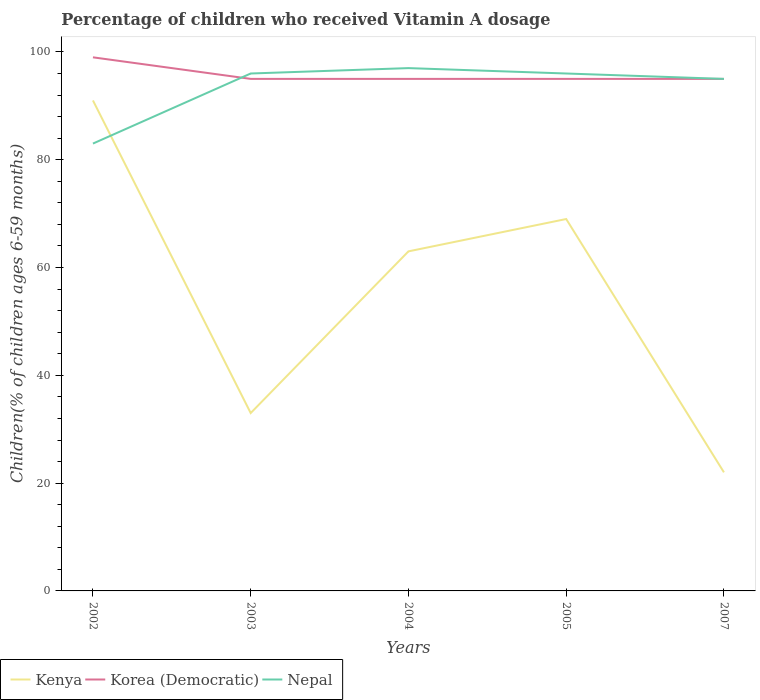How many different coloured lines are there?
Give a very brief answer. 3. Is the number of lines equal to the number of legend labels?
Offer a terse response. Yes. Across all years, what is the maximum percentage of children who received Vitamin A dosage in Nepal?
Your answer should be compact. 83. In which year was the percentage of children who received Vitamin A dosage in Kenya maximum?
Give a very brief answer. 2007. What is the difference between the highest and the second highest percentage of children who received Vitamin A dosage in Korea (Democratic)?
Offer a terse response. 4. What is the difference between the highest and the lowest percentage of children who received Vitamin A dosage in Korea (Democratic)?
Your answer should be compact. 1. Is the percentage of children who received Vitamin A dosage in Kenya strictly greater than the percentage of children who received Vitamin A dosage in Nepal over the years?
Ensure brevity in your answer.  No. How many lines are there?
Offer a very short reply. 3. Are the values on the major ticks of Y-axis written in scientific E-notation?
Make the answer very short. No. Does the graph contain any zero values?
Your response must be concise. No. Does the graph contain grids?
Give a very brief answer. No. How are the legend labels stacked?
Your answer should be compact. Horizontal. What is the title of the graph?
Give a very brief answer. Percentage of children who received Vitamin A dosage. Does "Lesotho" appear as one of the legend labels in the graph?
Your answer should be very brief. No. What is the label or title of the Y-axis?
Give a very brief answer. Children(% of children ages 6-59 months). What is the Children(% of children ages 6-59 months) in Kenya in 2002?
Keep it short and to the point. 91. What is the Children(% of children ages 6-59 months) of Nepal in 2002?
Ensure brevity in your answer.  83. What is the Children(% of children ages 6-59 months) of Nepal in 2003?
Give a very brief answer. 96. What is the Children(% of children ages 6-59 months) of Kenya in 2004?
Make the answer very short. 63. What is the Children(% of children ages 6-59 months) of Nepal in 2004?
Your answer should be compact. 97. What is the Children(% of children ages 6-59 months) of Kenya in 2005?
Give a very brief answer. 69. What is the Children(% of children ages 6-59 months) of Nepal in 2005?
Provide a succinct answer. 96. What is the Children(% of children ages 6-59 months) in Korea (Democratic) in 2007?
Your response must be concise. 95. Across all years, what is the maximum Children(% of children ages 6-59 months) in Kenya?
Make the answer very short. 91. Across all years, what is the maximum Children(% of children ages 6-59 months) of Korea (Democratic)?
Keep it short and to the point. 99. Across all years, what is the maximum Children(% of children ages 6-59 months) of Nepal?
Give a very brief answer. 97. Across all years, what is the minimum Children(% of children ages 6-59 months) of Kenya?
Ensure brevity in your answer.  22. Across all years, what is the minimum Children(% of children ages 6-59 months) in Korea (Democratic)?
Ensure brevity in your answer.  95. What is the total Children(% of children ages 6-59 months) in Kenya in the graph?
Offer a terse response. 278. What is the total Children(% of children ages 6-59 months) in Korea (Democratic) in the graph?
Offer a terse response. 479. What is the total Children(% of children ages 6-59 months) of Nepal in the graph?
Your answer should be very brief. 467. What is the difference between the Children(% of children ages 6-59 months) of Kenya in 2002 and that in 2003?
Provide a short and direct response. 58. What is the difference between the Children(% of children ages 6-59 months) of Nepal in 2002 and that in 2003?
Provide a short and direct response. -13. What is the difference between the Children(% of children ages 6-59 months) of Nepal in 2002 and that in 2004?
Make the answer very short. -14. What is the difference between the Children(% of children ages 6-59 months) of Kenya in 2002 and that in 2007?
Provide a succinct answer. 69. What is the difference between the Children(% of children ages 6-59 months) in Korea (Democratic) in 2002 and that in 2007?
Offer a very short reply. 4. What is the difference between the Children(% of children ages 6-59 months) in Nepal in 2002 and that in 2007?
Your answer should be compact. -12. What is the difference between the Children(% of children ages 6-59 months) of Kenya in 2003 and that in 2005?
Keep it short and to the point. -36. What is the difference between the Children(% of children ages 6-59 months) in Korea (Democratic) in 2003 and that in 2005?
Give a very brief answer. 0. What is the difference between the Children(% of children ages 6-59 months) in Nepal in 2003 and that in 2005?
Offer a terse response. 0. What is the difference between the Children(% of children ages 6-59 months) of Korea (Democratic) in 2003 and that in 2007?
Your answer should be compact. 0. What is the difference between the Children(% of children ages 6-59 months) of Nepal in 2003 and that in 2007?
Offer a very short reply. 1. What is the difference between the Children(% of children ages 6-59 months) of Korea (Democratic) in 2004 and that in 2005?
Give a very brief answer. 0. What is the difference between the Children(% of children ages 6-59 months) of Nepal in 2004 and that in 2005?
Your response must be concise. 1. What is the difference between the Children(% of children ages 6-59 months) in Kenya in 2005 and that in 2007?
Your answer should be compact. 47. What is the difference between the Children(% of children ages 6-59 months) of Korea (Democratic) in 2005 and that in 2007?
Your answer should be compact. 0. What is the difference between the Children(% of children ages 6-59 months) of Kenya in 2002 and the Children(% of children ages 6-59 months) of Korea (Democratic) in 2003?
Your answer should be compact. -4. What is the difference between the Children(% of children ages 6-59 months) in Kenya in 2002 and the Children(% of children ages 6-59 months) in Nepal in 2003?
Ensure brevity in your answer.  -5. What is the difference between the Children(% of children ages 6-59 months) of Kenya in 2002 and the Children(% of children ages 6-59 months) of Korea (Democratic) in 2004?
Keep it short and to the point. -4. What is the difference between the Children(% of children ages 6-59 months) of Korea (Democratic) in 2002 and the Children(% of children ages 6-59 months) of Nepal in 2004?
Your response must be concise. 2. What is the difference between the Children(% of children ages 6-59 months) in Korea (Democratic) in 2002 and the Children(% of children ages 6-59 months) in Nepal in 2005?
Ensure brevity in your answer.  3. What is the difference between the Children(% of children ages 6-59 months) of Kenya in 2003 and the Children(% of children ages 6-59 months) of Korea (Democratic) in 2004?
Ensure brevity in your answer.  -62. What is the difference between the Children(% of children ages 6-59 months) of Kenya in 2003 and the Children(% of children ages 6-59 months) of Nepal in 2004?
Provide a short and direct response. -64. What is the difference between the Children(% of children ages 6-59 months) in Kenya in 2003 and the Children(% of children ages 6-59 months) in Korea (Democratic) in 2005?
Offer a terse response. -62. What is the difference between the Children(% of children ages 6-59 months) in Kenya in 2003 and the Children(% of children ages 6-59 months) in Nepal in 2005?
Provide a short and direct response. -63. What is the difference between the Children(% of children ages 6-59 months) of Korea (Democratic) in 2003 and the Children(% of children ages 6-59 months) of Nepal in 2005?
Give a very brief answer. -1. What is the difference between the Children(% of children ages 6-59 months) in Kenya in 2003 and the Children(% of children ages 6-59 months) in Korea (Democratic) in 2007?
Give a very brief answer. -62. What is the difference between the Children(% of children ages 6-59 months) in Kenya in 2003 and the Children(% of children ages 6-59 months) in Nepal in 2007?
Give a very brief answer. -62. What is the difference between the Children(% of children ages 6-59 months) in Kenya in 2004 and the Children(% of children ages 6-59 months) in Korea (Democratic) in 2005?
Ensure brevity in your answer.  -32. What is the difference between the Children(% of children ages 6-59 months) in Kenya in 2004 and the Children(% of children ages 6-59 months) in Nepal in 2005?
Give a very brief answer. -33. What is the difference between the Children(% of children ages 6-59 months) in Kenya in 2004 and the Children(% of children ages 6-59 months) in Korea (Democratic) in 2007?
Ensure brevity in your answer.  -32. What is the difference between the Children(% of children ages 6-59 months) of Kenya in 2004 and the Children(% of children ages 6-59 months) of Nepal in 2007?
Give a very brief answer. -32. What is the difference between the Children(% of children ages 6-59 months) in Kenya in 2005 and the Children(% of children ages 6-59 months) in Korea (Democratic) in 2007?
Give a very brief answer. -26. What is the difference between the Children(% of children ages 6-59 months) in Kenya in 2005 and the Children(% of children ages 6-59 months) in Nepal in 2007?
Ensure brevity in your answer.  -26. What is the difference between the Children(% of children ages 6-59 months) of Korea (Democratic) in 2005 and the Children(% of children ages 6-59 months) of Nepal in 2007?
Offer a very short reply. 0. What is the average Children(% of children ages 6-59 months) of Kenya per year?
Provide a succinct answer. 55.6. What is the average Children(% of children ages 6-59 months) in Korea (Democratic) per year?
Keep it short and to the point. 95.8. What is the average Children(% of children ages 6-59 months) in Nepal per year?
Provide a short and direct response. 93.4. In the year 2002, what is the difference between the Children(% of children ages 6-59 months) of Kenya and Children(% of children ages 6-59 months) of Nepal?
Your response must be concise. 8. In the year 2002, what is the difference between the Children(% of children ages 6-59 months) of Korea (Democratic) and Children(% of children ages 6-59 months) of Nepal?
Provide a short and direct response. 16. In the year 2003, what is the difference between the Children(% of children ages 6-59 months) in Kenya and Children(% of children ages 6-59 months) in Korea (Democratic)?
Your answer should be compact. -62. In the year 2003, what is the difference between the Children(% of children ages 6-59 months) in Kenya and Children(% of children ages 6-59 months) in Nepal?
Offer a terse response. -63. In the year 2003, what is the difference between the Children(% of children ages 6-59 months) of Korea (Democratic) and Children(% of children ages 6-59 months) of Nepal?
Give a very brief answer. -1. In the year 2004, what is the difference between the Children(% of children ages 6-59 months) of Kenya and Children(% of children ages 6-59 months) of Korea (Democratic)?
Ensure brevity in your answer.  -32. In the year 2004, what is the difference between the Children(% of children ages 6-59 months) in Kenya and Children(% of children ages 6-59 months) in Nepal?
Make the answer very short. -34. In the year 2004, what is the difference between the Children(% of children ages 6-59 months) in Korea (Democratic) and Children(% of children ages 6-59 months) in Nepal?
Your answer should be very brief. -2. In the year 2005, what is the difference between the Children(% of children ages 6-59 months) of Kenya and Children(% of children ages 6-59 months) of Korea (Democratic)?
Offer a very short reply. -26. In the year 2005, what is the difference between the Children(% of children ages 6-59 months) of Korea (Democratic) and Children(% of children ages 6-59 months) of Nepal?
Offer a very short reply. -1. In the year 2007, what is the difference between the Children(% of children ages 6-59 months) of Kenya and Children(% of children ages 6-59 months) of Korea (Democratic)?
Your answer should be compact. -73. In the year 2007, what is the difference between the Children(% of children ages 6-59 months) in Kenya and Children(% of children ages 6-59 months) in Nepal?
Ensure brevity in your answer.  -73. In the year 2007, what is the difference between the Children(% of children ages 6-59 months) of Korea (Democratic) and Children(% of children ages 6-59 months) of Nepal?
Your response must be concise. 0. What is the ratio of the Children(% of children ages 6-59 months) of Kenya in 2002 to that in 2003?
Your answer should be very brief. 2.76. What is the ratio of the Children(% of children ages 6-59 months) of Korea (Democratic) in 2002 to that in 2003?
Give a very brief answer. 1.04. What is the ratio of the Children(% of children ages 6-59 months) of Nepal in 2002 to that in 2003?
Your answer should be very brief. 0.86. What is the ratio of the Children(% of children ages 6-59 months) of Kenya in 2002 to that in 2004?
Your answer should be compact. 1.44. What is the ratio of the Children(% of children ages 6-59 months) in Korea (Democratic) in 2002 to that in 2004?
Give a very brief answer. 1.04. What is the ratio of the Children(% of children ages 6-59 months) in Nepal in 2002 to that in 2004?
Keep it short and to the point. 0.86. What is the ratio of the Children(% of children ages 6-59 months) of Kenya in 2002 to that in 2005?
Offer a very short reply. 1.32. What is the ratio of the Children(% of children ages 6-59 months) in Korea (Democratic) in 2002 to that in 2005?
Offer a terse response. 1.04. What is the ratio of the Children(% of children ages 6-59 months) of Nepal in 2002 to that in 2005?
Provide a short and direct response. 0.86. What is the ratio of the Children(% of children ages 6-59 months) of Kenya in 2002 to that in 2007?
Your response must be concise. 4.14. What is the ratio of the Children(% of children ages 6-59 months) in Korea (Democratic) in 2002 to that in 2007?
Provide a short and direct response. 1.04. What is the ratio of the Children(% of children ages 6-59 months) of Nepal in 2002 to that in 2007?
Ensure brevity in your answer.  0.87. What is the ratio of the Children(% of children ages 6-59 months) of Kenya in 2003 to that in 2004?
Keep it short and to the point. 0.52. What is the ratio of the Children(% of children ages 6-59 months) in Korea (Democratic) in 2003 to that in 2004?
Your response must be concise. 1. What is the ratio of the Children(% of children ages 6-59 months) of Kenya in 2003 to that in 2005?
Make the answer very short. 0.48. What is the ratio of the Children(% of children ages 6-59 months) of Korea (Democratic) in 2003 to that in 2005?
Provide a short and direct response. 1. What is the ratio of the Children(% of children ages 6-59 months) in Kenya in 2003 to that in 2007?
Provide a short and direct response. 1.5. What is the ratio of the Children(% of children ages 6-59 months) of Nepal in 2003 to that in 2007?
Ensure brevity in your answer.  1.01. What is the ratio of the Children(% of children ages 6-59 months) of Nepal in 2004 to that in 2005?
Keep it short and to the point. 1.01. What is the ratio of the Children(% of children ages 6-59 months) of Kenya in 2004 to that in 2007?
Your answer should be very brief. 2.86. What is the ratio of the Children(% of children ages 6-59 months) in Nepal in 2004 to that in 2007?
Provide a short and direct response. 1.02. What is the ratio of the Children(% of children ages 6-59 months) in Kenya in 2005 to that in 2007?
Offer a terse response. 3.14. What is the ratio of the Children(% of children ages 6-59 months) in Nepal in 2005 to that in 2007?
Keep it short and to the point. 1.01. What is the difference between the highest and the second highest Children(% of children ages 6-59 months) of Kenya?
Ensure brevity in your answer.  22. What is the difference between the highest and the second highest Children(% of children ages 6-59 months) of Nepal?
Offer a terse response. 1. What is the difference between the highest and the lowest Children(% of children ages 6-59 months) in Kenya?
Offer a terse response. 69. What is the difference between the highest and the lowest Children(% of children ages 6-59 months) of Korea (Democratic)?
Your response must be concise. 4. What is the difference between the highest and the lowest Children(% of children ages 6-59 months) of Nepal?
Make the answer very short. 14. 